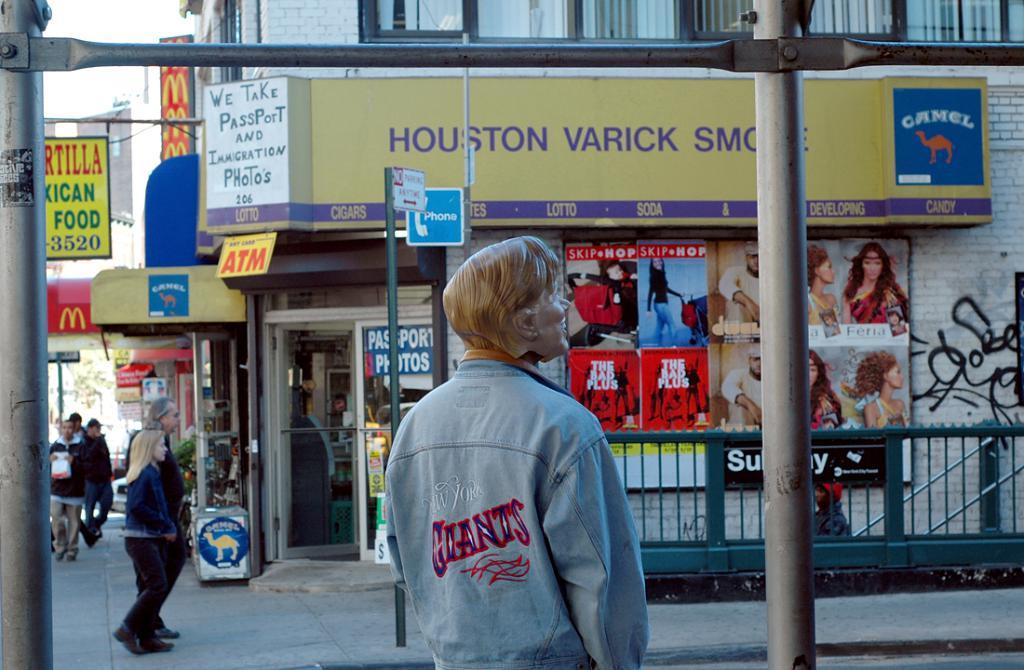What are the two persons in the image doing? The two persons are walking on the footpath on the left side of the image. What can be found on the left side of the image besides the persons walking? There are stores on the left side of the image. What is on the right side of the image? There are papers stuck to the wall on the right side of the image. What type of thread is being used to hold the papers on the wall in the image? A: There is no thread visible in the image; the papers are stuck to the wall using an unknown method. 